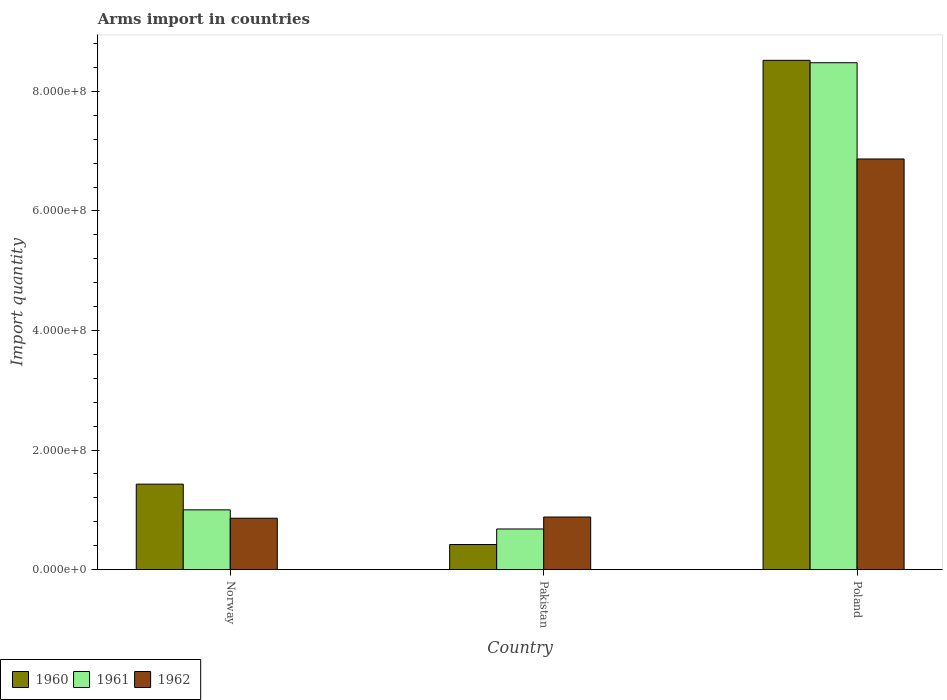How many bars are there on the 2nd tick from the left?
Make the answer very short. 3. How many bars are there on the 3rd tick from the right?
Your answer should be compact. 3. In how many cases, is the number of bars for a given country not equal to the number of legend labels?
Offer a very short reply. 0. What is the total arms import in 1961 in Norway?
Provide a succinct answer. 1.00e+08. Across all countries, what is the maximum total arms import in 1962?
Keep it short and to the point. 6.87e+08. Across all countries, what is the minimum total arms import in 1960?
Your answer should be very brief. 4.20e+07. In which country was the total arms import in 1960 maximum?
Keep it short and to the point. Poland. What is the total total arms import in 1960 in the graph?
Your response must be concise. 1.04e+09. What is the difference between the total arms import in 1961 in Pakistan and that in Poland?
Your response must be concise. -7.80e+08. What is the difference between the total arms import in 1960 in Norway and the total arms import in 1962 in Poland?
Your answer should be very brief. -5.44e+08. What is the average total arms import in 1960 per country?
Provide a succinct answer. 3.46e+08. What is the difference between the total arms import of/in 1960 and total arms import of/in 1961 in Pakistan?
Offer a very short reply. -2.60e+07. What is the ratio of the total arms import in 1962 in Norway to that in Pakistan?
Offer a very short reply. 0.98. Is the difference between the total arms import in 1960 in Norway and Poland greater than the difference between the total arms import in 1961 in Norway and Poland?
Offer a terse response. Yes. What is the difference between the highest and the second highest total arms import in 1960?
Keep it short and to the point. 8.10e+08. What is the difference between the highest and the lowest total arms import in 1961?
Make the answer very short. 7.80e+08. What does the 1st bar from the left in Pakistan represents?
Make the answer very short. 1960. What does the 3rd bar from the right in Pakistan represents?
Your answer should be compact. 1960. Is it the case that in every country, the sum of the total arms import in 1962 and total arms import in 1960 is greater than the total arms import in 1961?
Your answer should be very brief. Yes. How many bars are there?
Provide a short and direct response. 9. What is the difference between two consecutive major ticks on the Y-axis?
Offer a very short reply. 2.00e+08. Does the graph contain any zero values?
Offer a terse response. No. What is the title of the graph?
Give a very brief answer. Arms import in countries. What is the label or title of the X-axis?
Your response must be concise. Country. What is the label or title of the Y-axis?
Keep it short and to the point. Import quantity. What is the Import quantity in 1960 in Norway?
Offer a terse response. 1.43e+08. What is the Import quantity in 1961 in Norway?
Your answer should be very brief. 1.00e+08. What is the Import quantity of 1962 in Norway?
Provide a short and direct response. 8.60e+07. What is the Import quantity of 1960 in Pakistan?
Provide a succinct answer. 4.20e+07. What is the Import quantity in 1961 in Pakistan?
Offer a terse response. 6.80e+07. What is the Import quantity in 1962 in Pakistan?
Provide a succinct answer. 8.80e+07. What is the Import quantity in 1960 in Poland?
Your answer should be very brief. 8.52e+08. What is the Import quantity of 1961 in Poland?
Provide a short and direct response. 8.48e+08. What is the Import quantity in 1962 in Poland?
Ensure brevity in your answer.  6.87e+08. Across all countries, what is the maximum Import quantity of 1960?
Offer a very short reply. 8.52e+08. Across all countries, what is the maximum Import quantity in 1961?
Give a very brief answer. 8.48e+08. Across all countries, what is the maximum Import quantity in 1962?
Offer a very short reply. 6.87e+08. Across all countries, what is the minimum Import quantity of 1960?
Make the answer very short. 4.20e+07. Across all countries, what is the minimum Import quantity of 1961?
Give a very brief answer. 6.80e+07. Across all countries, what is the minimum Import quantity in 1962?
Your response must be concise. 8.60e+07. What is the total Import quantity in 1960 in the graph?
Provide a succinct answer. 1.04e+09. What is the total Import quantity in 1961 in the graph?
Your answer should be compact. 1.02e+09. What is the total Import quantity in 1962 in the graph?
Provide a succinct answer. 8.61e+08. What is the difference between the Import quantity of 1960 in Norway and that in Pakistan?
Your response must be concise. 1.01e+08. What is the difference between the Import quantity in 1961 in Norway and that in Pakistan?
Offer a very short reply. 3.20e+07. What is the difference between the Import quantity of 1960 in Norway and that in Poland?
Provide a short and direct response. -7.09e+08. What is the difference between the Import quantity in 1961 in Norway and that in Poland?
Provide a short and direct response. -7.48e+08. What is the difference between the Import quantity in 1962 in Norway and that in Poland?
Ensure brevity in your answer.  -6.01e+08. What is the difference between the Import quantity in 1960 in Pakistan and that in Poland?
Your answer should be very brief. -8.10e+08. What is the difference between the Import quantity of 1961 in Pakistan and that in Poland?
Offer a terse response. -7.80e+08. What is the difference between the Import quantity of 1962 in Pakistan and that in Poland?
Provide a succinct answer. -5.99e+08. What is the difference between the Import quantity in 1960 in Norway and the Import quantity in 1961 in Pakistan?
Provide a short and direct response. 7.50e+07. What is the difference between the Import quantity in 1960 in Norway and the Import quantity in 1962 in Pakistan?
Your answer should be compact. 5.50e+07. What is the difference between the Import quantity in 1961 in Norway and the Import quantity in 1962 in Pakistan?
Keep it short and to the point. 1.20e+07. What is the difference between the Import quantity in 1960 in Norway and the Import quantity in 1961 in Poland?
Your answer should be very brief. -7.05e+08. What is the difference between the Import quantity of 1960 in Norway and the Import quantity of 1962 in Poland?
Give a very brief answer. -5.44e+08. What is the difference between the Import quantity in 1961 in Norway and the Import quantity in 1962 in Poland?
Give a very brief answer. -5.87e+08. What is the difference between the Import quantity in 1960 in Pakistan and the Import quantity in 1961 in Poland?
Your response must be concise. -8.06e+08. What is the difference between the Import quantity in 1960 in Pakistan and the Import quantity in 1962 in Poland?
Offer a very short reply. -6.45e+08. What is the difference between the Import quantity of 1961 in Pakistan and the Import quantity of 1962 in Poland?
Your response must be concise. -6.19e+08. What is the average Import quantity in 1960 per country?
Make the answer very short. 3.46e+08. What is the average Import quantity of 1961 per country?
Your response must be concise. 3.39e+08. What is the average Import quantity in 1962 per country?
Offer a very short reply. 2.87e+08. What is the difference between the Import quantity in 1960 and Import quantity in 1961 in Norway?
Keep it short and to the point. 4.30e+07. What is the difference between the Import quantity in 1960 and Import quantity in 1962 in Norway?
Provide a short and direct response. 5.70e+07. What is the difference between the Import quantity in 1961 and Import quantity in 1962 in Norway?
Keep it short and to the point. 1.40e+07. What is the difference between the Import quantity of 1960 and Import quantity of 1961 in Pakistan?
Make the answer very short. -2.60e+07. What is the difference between the Import quantity of 1960 and Import quantity of 1962 in Pakistan?
Give a very brief answer. -4.60e+07. What is the difference between the Import quantity of 1961 and Import quantity of 1962 in Pakistan?
Provide a short and direct response. -2.00e+07. What is the difference between the Import quantity in 1960 and Import quantity in 1962 in Poland?
Make the answer very short. 1.65e+08. What is the difference between the Import quantity in 1961 and Import quantity in 1962 in Poland?
Provide a succinct answer. 1.61e+08. What is the ratio of the Import quantity of 1960 in Norway to that in Pakistan?
Provide a short and direct response. 3.4. What is the ratio of the Import quantity of 1961 in Norway to that in Pakistan?
Keep it short and to the point. 1.47. What is the ratio of the Import quantity of 1962 in Norway to that in Pakistan?
Your answer should be very brief. 0.98. What is the ratio of the Import quantity of 1960 in Norway to that in Poland?
Offer a very short reply. 0.17. What is the ratio of the Import quantity in 1961 in Norway to that in Poland?
Keep it short and to the point. 0.12. What is the ratio of the Import quantity of 1962 in Norway to that in Poland?
Ensure brevity in your answer.  0.13. What is the ratio of the Import quantity of 1960 in Pakistan to that in Poland?
Provide a short and direct response. 0.05. What is the ratio of the Import quantity of 1961 in Pakistan to that in Poland?
Offer a terse response. 0.08. What is the ratio of the Import quantity of 1962 in Pakistan to that in Poland?
Your response must be concise. 0.13. What is the difference between the highest and the second highest Import quantity in 1960?
Keep it short and to the point. 7.09e+08. What is the difference between the highest and the second highest Import quantity of 1961?
Provide a succinct answer. 7.48e+08. What is the difference between the highest and the second highest Import quantity in 1962?
Make the answer very short. 5.99e+08. What is the difference between the highest and the lowest Import quantity in 1960?
Ensure brevity in your answer.  8.10e+08. What is the difference between the highest and the lowest Import quantity in 1961?
Give a very brief answer. 7.80e+08. What is the difference between the highest and the lowest Import quantity in 1962?
Make the answer very short. 6.01e+08. 